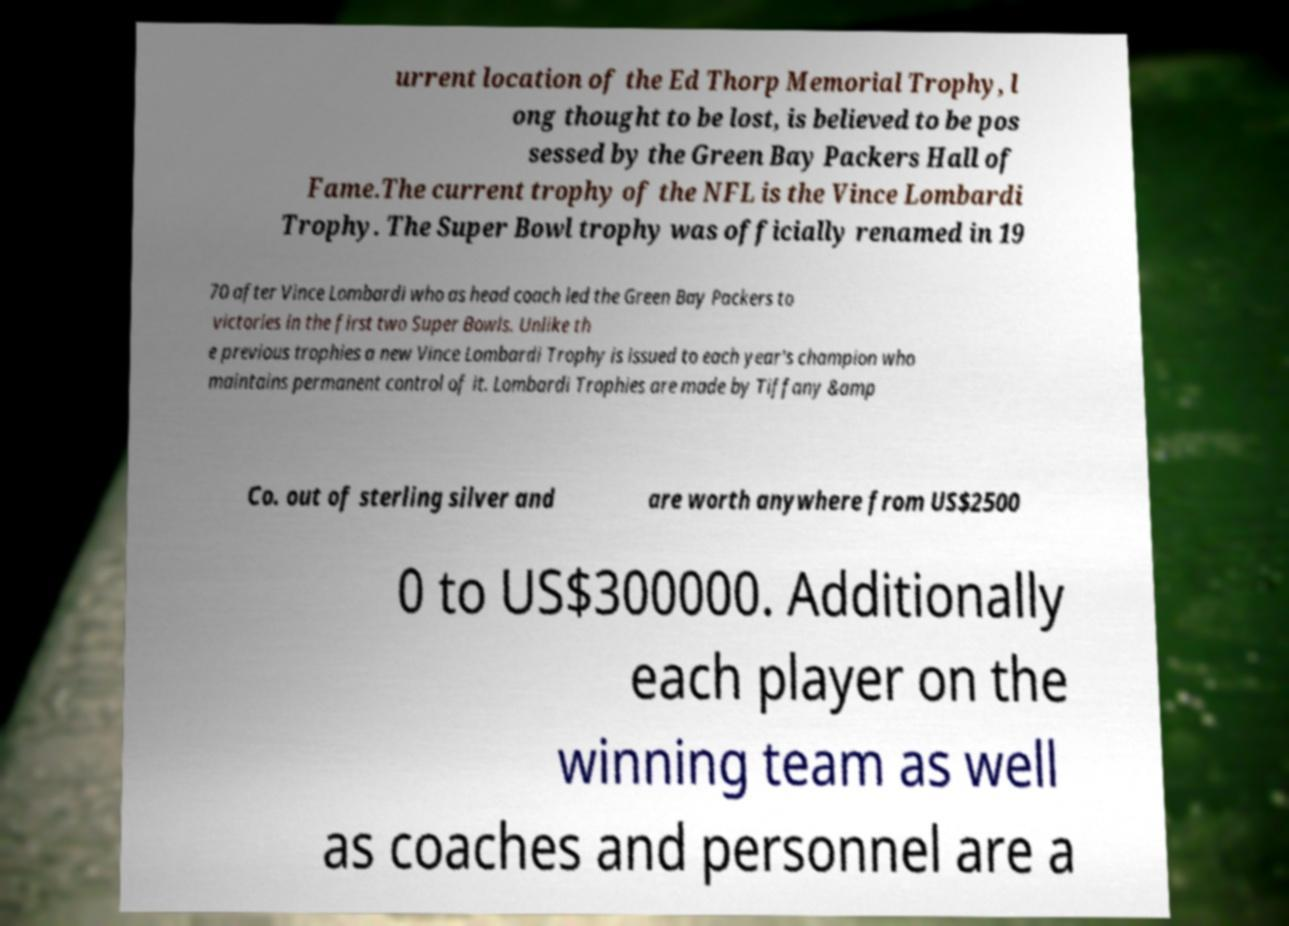Can you read and provide the text displayed in the image?This photo seems to have some interesting text. Can you extract and type it out for me? urrent location of the Ed Thorp Memorial Trophy, l ong thought to be lost, is believed to be pos sessed by the Green Bay Packers Hall of Fame.The current trophy of the NFL is the Vince Lombardi Trophy. The Super Bowl trophy was officially renamed in 19 70 after Vince Lombardi who as head coach led the Green Bay Packers to victories in the first two Super Bowls. Unlike th e previous trophies a new Vince Lombardi Trophy is issued to each year's champion who maintains permanent control of it. Lombardi Trophies are made by Tiffany &amp Co. out of sterling silver and are worth anywhere from US$2500 0 to US$300000. Additionally each player on the winning team as well as coaches and personnel are a 